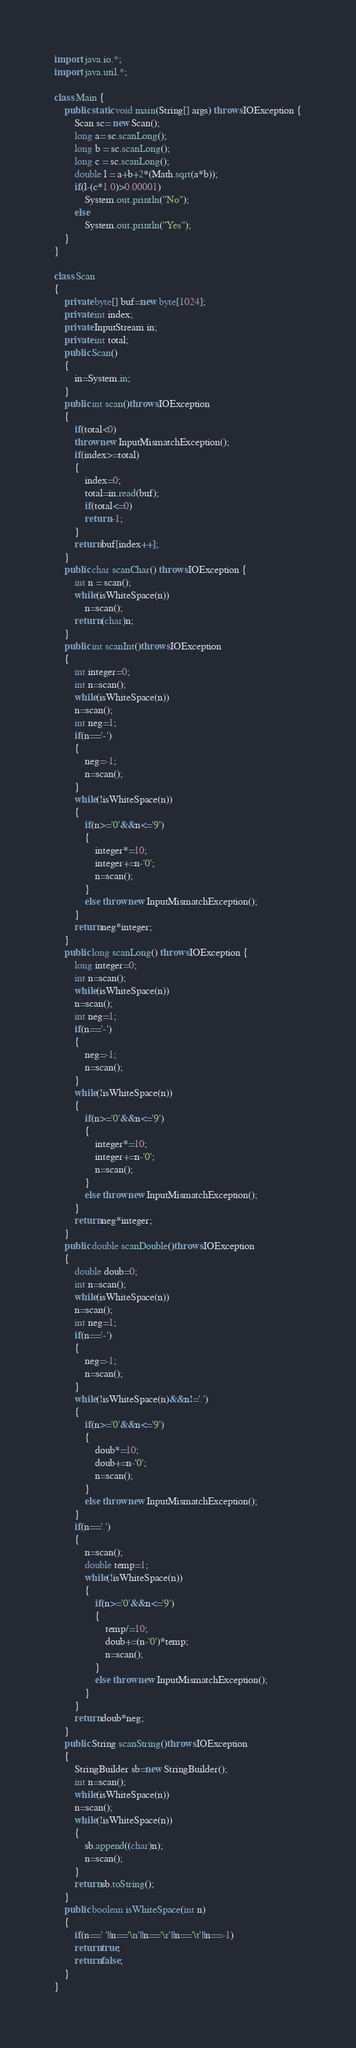Convert code to text. <code><loc_0><loc_0><loc_500><loc_500><_Java_>import java.io.*;
import java.util.*;

class Main {
    public static void main(String[] args) throws IOException {
        Scan sc= new Scan();
        long a= sc.scanLong();
        long b = sc.scanLong();
        long c = sc.scanLong();
        double l = a+b+2*(Math.sqrt(a*b));
        if(l-(c*1.0)>0.00001)
            System.out.println("No");
        else
            System.out.println("Yes");
    }
}

class Scan
{
    private byte[] buf=new byte[1024];
    private int index;
    private InputStream in;
    private int total;
    public Scan()
    {
        in=System.in;
    }
    public int scan()throws IOException
    {
        if(total<0)
        throw new InputMismatchException();
        if(index>=total)
        {
            index=0;
            total=in.read(buf);
            if(total<=0)
            return -1;
        }
        return buf[index++];
    }
    public char scanChar() throws IOException {
        int n = scan();
        while(isWhiteSpace(n))
            n=scan();
        return (char)n;
    }
    public int scanInt()throws IOException
    {
        int integer=0;
        int n=scan();
        while(isWhiteSpace(n))
        n=scan();
        int neg=1;
        if(n=='-')
        {
            neg=-1;
            n=scan();
        }
        while(!isWhiteSpace(n))
        {
            if(n>='0'&&n<='9')
            {
                integer*=10;
                integer+=n-'0';
                n=scan();
            }
            else throw new InputMismatchException();
        }
        return neg*integer;
    }
    public long scanLong() throws IOException {
        long integer=0;
        int n=scan();
        while(isWhiteSpace(n))
        n=scan();
        int neg=1;
        if(n=='-')
        {
            neg=-1;
            n=scan();
        }
        while(!isWhiteSpace(n))
        {
            if(n>='0'&&n<='9')
            {
                integer*=10;
                integer+=n-'0';
                n=scan();
            }
            else throw new InputMismatchException();
        }
        return neg*integer;
    }
    public double scanDouble()throws IOException
    {
        double doub=0;
        int n=scan();
        while(isWhiteSpace(n))
        n=scan();
        int neg=1;
        if(n=='-')
        {
            neg=-1;
            n=scan();
        }
        while(!isWhiteSpace(n)&&n!='.')
        {
            if(n>='0'&&n<='9')
            {
                doub*=10;
                doub+=n-'0';
                n=scan();
            }
            else throw new InputMismatchException();
        }
        if(n=='.')
        {
            n=scan();
            double temp=1;
            while(!isWhiteSpace(n))
            {
                if(n>='0'&&n<='9')
                {
                    temp/=10;
                    doub+=(n-'0')*temp;
                    n=scan();
                }
                else throw new InputMismatchException();
            }
        }
        return doub*neg;
    }
    public String scanString()throws IOException
    {
        StringBuilder sb=new StringBuilder();
        int n=scan();
        while(isWhiteSpace(n))
        n=scan();
        while(!isWhiteSpace(n))
        {
            sb.append((char)n);
            n=scan();
        }
        return sb.toString();
    }
    public boolean isWhiteSpace(int n)
    {
        if(n==' '||n=='\n'||n=='\r'||n=='\t'||n==-1)
        return true;
        return false;
    }
}
</code> 